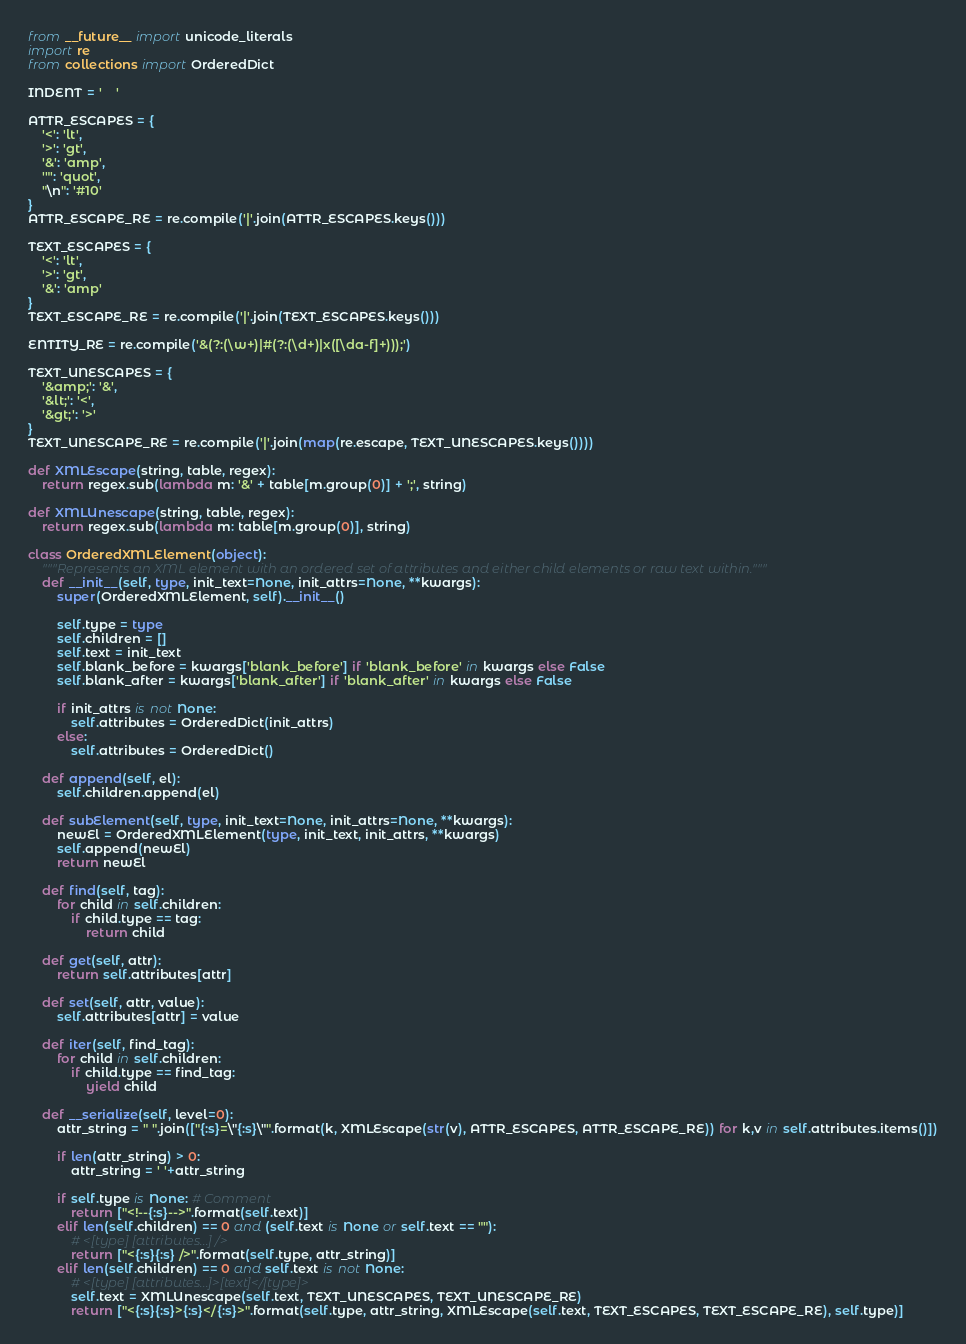Convert code to text. <code><loc_0><loc_0><loc_500><loc_500><_Python_>from __future__ import unicode_literals
import re
from collections import OrderedDict

INDENT = '    '

ATTR_ESCAPES = {
    '<': 'lt',
    '>': 'gt',
    '&': 'amp',
    '"': 'quot',
    "\n": '#10'
}
ATTR_ESCAPE_RE = re.compile('|'.join(ATTR_ESCAPES.keys()))

TEXT_ESCAPES = {
    '<': 'lt',
    '>': 'gt',
    '&': 'amp'
}
TEXT_ESCAPE_RE = re.compile('|'.join(TEXT_ESCAPES.keys()))

ENTITY_RE = re.compile('&(?:(\w+)|#(?:(\d+)|x([\da-f]+)));')

TEXT_UNESCAPES = {
    '&amp;': '&',
    '&lt;': '<',
    '&gt;': '>'
}
TEXT_UNESCAPE_RE = re.compile('|'.join(map(re.escape, TEXT_UNESCAPES.keys())))

def XMLEscape(string, table, regex):
    return regex.sub(lambda m: '&' + table[m.group(0)] + ';', string)

def XMLUnescape(string, table, regex):
    return regex.sub(lambda m: table[m.group(0)], string)

class OrderedXMLElement(object):
    """Represents an XML element with an ordered set of attributes and either child elements or raw text within."""
    def __init__(self, type, init_text=None, init_attrs=None, **kwargs):
        super(OrderedXMLElement, self).__init__()
        
        self.type = type
        self.children = []
        self.text = init_text
        self.blank_before = kwargs['blank_before'] if 'blank_before' in kwargs else False
        self.blank_after = kwargs['blank_after'] if 'blank_after' in kwargs else False
        
        if init_attrs is not None:
            self.attributes = OrderedDict(init_attrs)
        else:
            self.attributes = OrderedDict()

    def append(self, el):
        self.children.append(el)

    def subElement(self, type, init_text=None, init_attrs=None, **kwargs):
        newEl = OrderedXMLElement(type, init_text, init_attrs, **kwargs)
        self.append(newEl)
        return newEl
        
    def find(self, tag):
        for child in self.children:
            if child.type == tag:
                return child
                
    def get(self, attr):
        return self.attributes[attr]

    def set(self, attr, value):
        self.attributes[attr] = value
        
    def iter(self, find_tag):
        for child in self.children:
            if child.type == find_tag:
                yield child

    def __serialize(self, level=0):
        attr_string = " ".join(["{:s}=\"{:s}\"".format(k, XMLEscape(str(v), ATTR_ESCAPES, ATTR_ESCAPE_RE)) for k,v in self.attributes.items()])
        
        if len(attr_string) > 0:
            attr_string = ' '+attr_string

        if self.type is None: # Comment
            return ["<!--{:s}-->".format(self.text)]
        elif len(self.children) == 0 and (self.text is None or self.text == ""):
            # <[type] [attributes...] />
            return ["<{:s}{:s} />".format(self.type, attr_string)]
        elif len(self.children) == 0 and self.text is not None:
            # <[type] [attributes...]>[text]</[type]>
            self.text = XMLUnescape(self.text, TEXT_UNESCAPES, TEXT_UNESCAPE_RE)
            return ["<{:s}{:s}>{:s}</{:s}>".format(self.type, attr_string, XMLEscape(self.text, TEXT_ESCAPES, TEXT_ESCAPE_RE), self.type)]</code> 